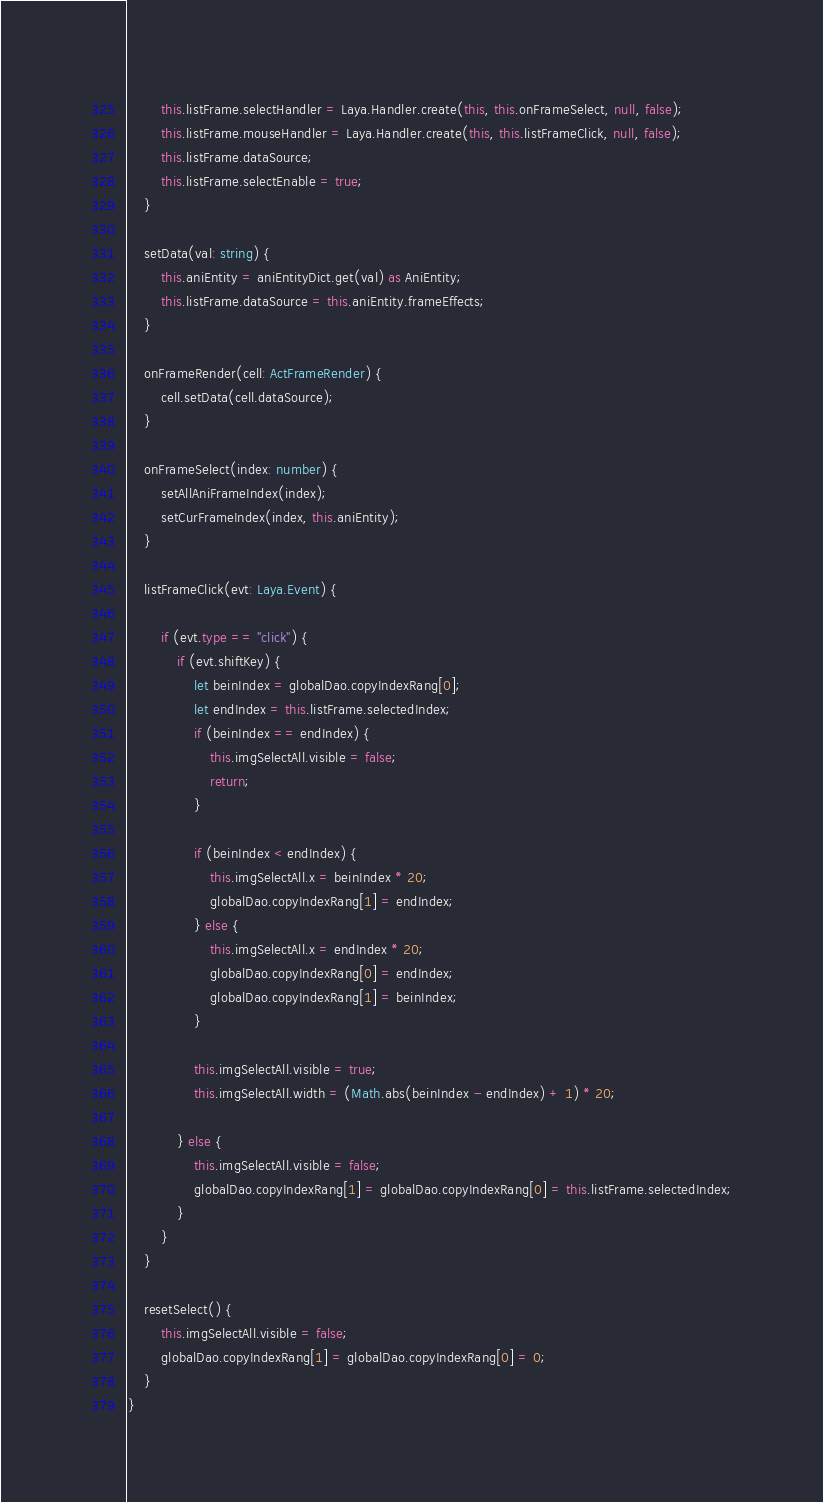<code> <loc_0><loc_0><loc_500><loc_500><_TypeScript_>        this.listFrame.selectHandler = Laya.Handler.create(this, this.onFrameSelect, null, false);
        this.listFrame.mouseHandler = Laya.Handler.create(this, this.listFrameClick, null, false);
        this.listFrame.dataSource;
        this.listFrame.selectEnable = true;
    }

    setData(val: string) {
        this.aniEntity = aniEntityDict.get(val) as AniEntity;
        this.listFrame.dataSource = this.aniEntity.frameEffects;
    }

    onFrameRender(cell: ActFrameRender) {
        cell.setData(cell.dataSource);
    }

    onFrameSelect(index: number) {
        setAllAniFrameIndex(index);
        setCurFrameIndex(index, this.aniEntity);
    }

    listFrameClick(evt: Laya.Event) {

        if (evt.type == "click") {
            if (evt.shiftKey) {
                let beinIndex = globalDao.copyIndexRang[0];
                let endIndex = this.listFrame.selectedIndex;
                if (beinIndex == endIndex) {
                    this.imgSelectAll.visible = false;
                    return;
                }

                if (beinIndex < endIndex) {
                    this.imgSelectAll.x = beinIndex * 20;
                    globalDao.copyIndexRang[1] = endIndex;
                } else {
                    this.imgSelectAll.x = endIndex * 20;
                    globalDao.copyIndexRang[0] = endIndex;
                    globalDao.copyIndexRang[1] = beinIndex;
                }

                this.imgSelectAll.visible = true;
                this.imgSelectAll.width = (Math.abs(beinIndex - endIndex) + 1) * 20;

            } else {
                this.imgSelectAll.visible = false;
                globalDao.copyIndexRang[1] = globalDao.copyIndexRang[0] = this.listFrame.selectedIndex;
            }
        }
    }

    resetSelect() {
        this.imgSelectAll.visible = false;
        globalDao.copyIndexRang[1] = globalDao.copyIndexRang[0] = 0;
    }
}</code> 